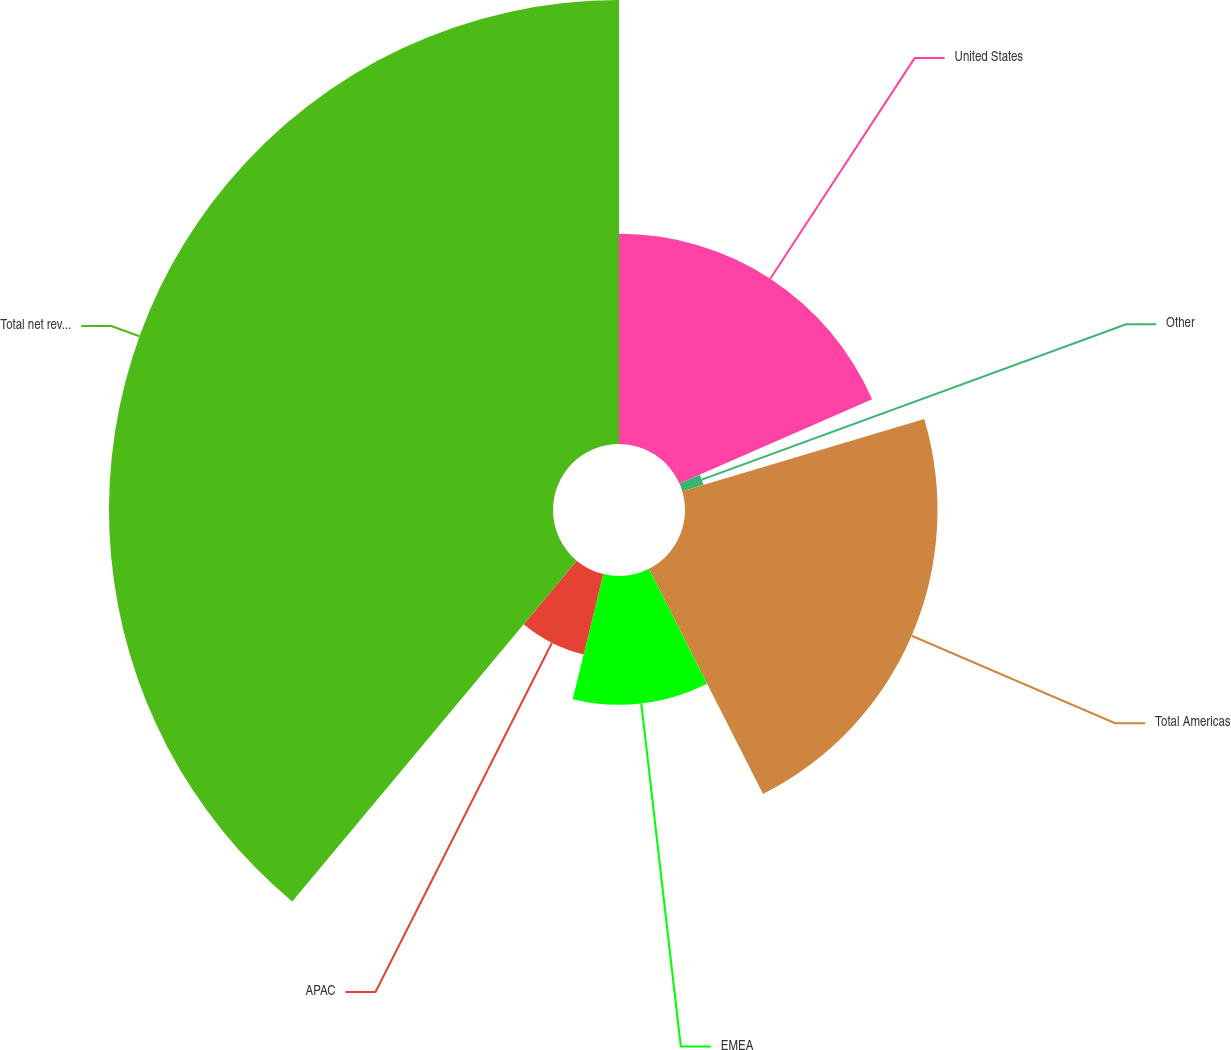<chart> <loc_0><loc_0><loc_500><loc_500><pie_chart><fcel>United States<fcel>Other<fcel>Total Americas<fcel>EMEA<fcel>APAC<fcel>Total net revenues<nl><fcel>18.44%<fcel>1.95%<fcel>22.14%<fcel>11.29%<fcel>7.25%<fcel>38.93%<nl></chart> 